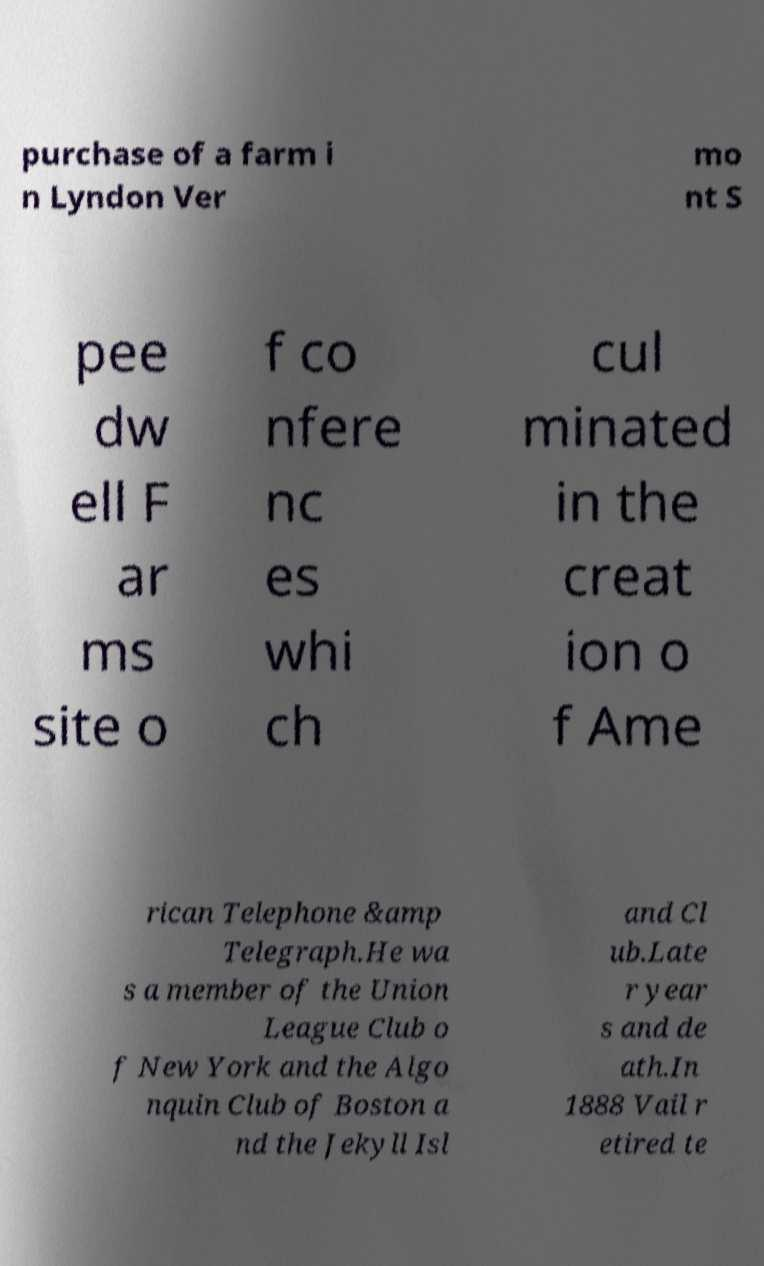Could you extract and type out the text from this image? purchase of a farm i n Lyndon Ver mo nt S pee dw ell F ar ms site o f co nfere nc es whi ch cul minated in the creat ion o f Ame rican Telephone &amp Telegraph.He wa s a member of the Union League Club o f New York and the Algo nquin Club of Boston a nd the Jekyll Isl and Cl ub.Late r year s and de ath.In 1888 Vail r etired te 